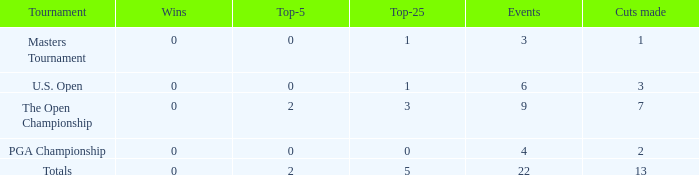How many total cuts were made in events with more than 0 wins and exactly 0 top-5s? 0.0. 